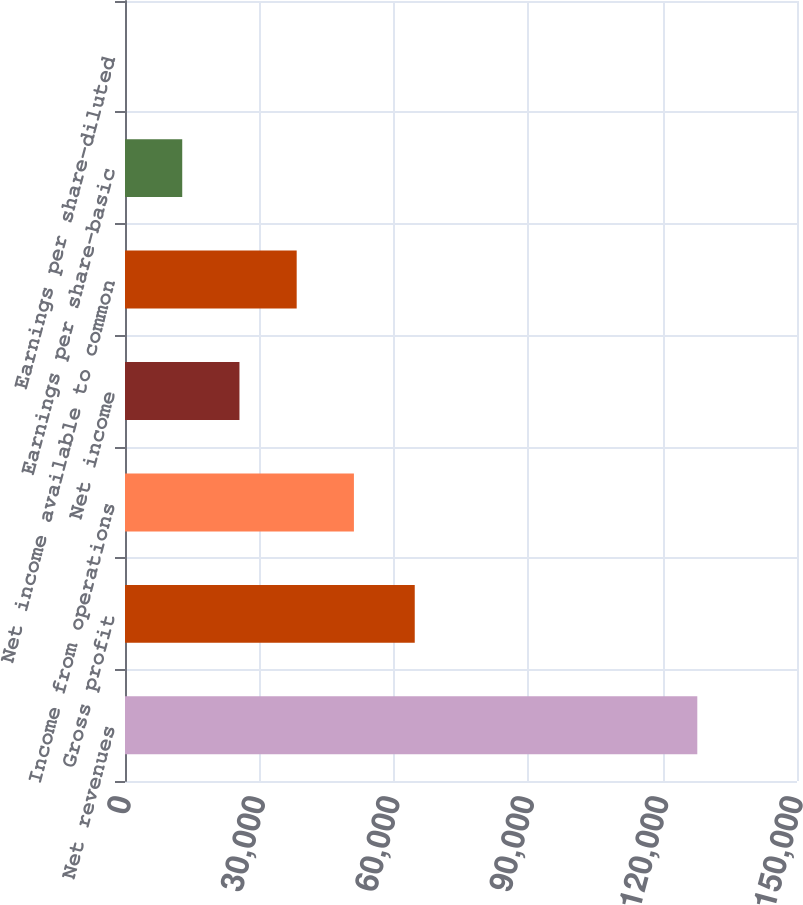Convert chart to OTSL. <chart><loc_0><loc_0><loc_500><loc_500><bar_chart><fcel>Net revenues<fcel>Gross profit<fcel>Income from operations<fcel>Net income<fcel>Net income available to common<fcel>Earnings per share-basic<fcel>Earnings per share-diluted<nl><fcel>127745<fcel>64675<fcel>51098.2<fcel>25549.3<fcel>38323.7<fcel>12774.8<fcel>0.32<nl></chart> 